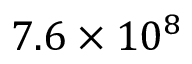<formula> <loc_0><loc_0><loc_500><loc_500>7 . 6 \times 1 0 ^ { 8 }</formula> 